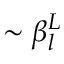Convert formula to latex. <formula><loc_0><loc_0><loc_500><loc_500>\sim \beta _ { l } ^ { L }</formula> 